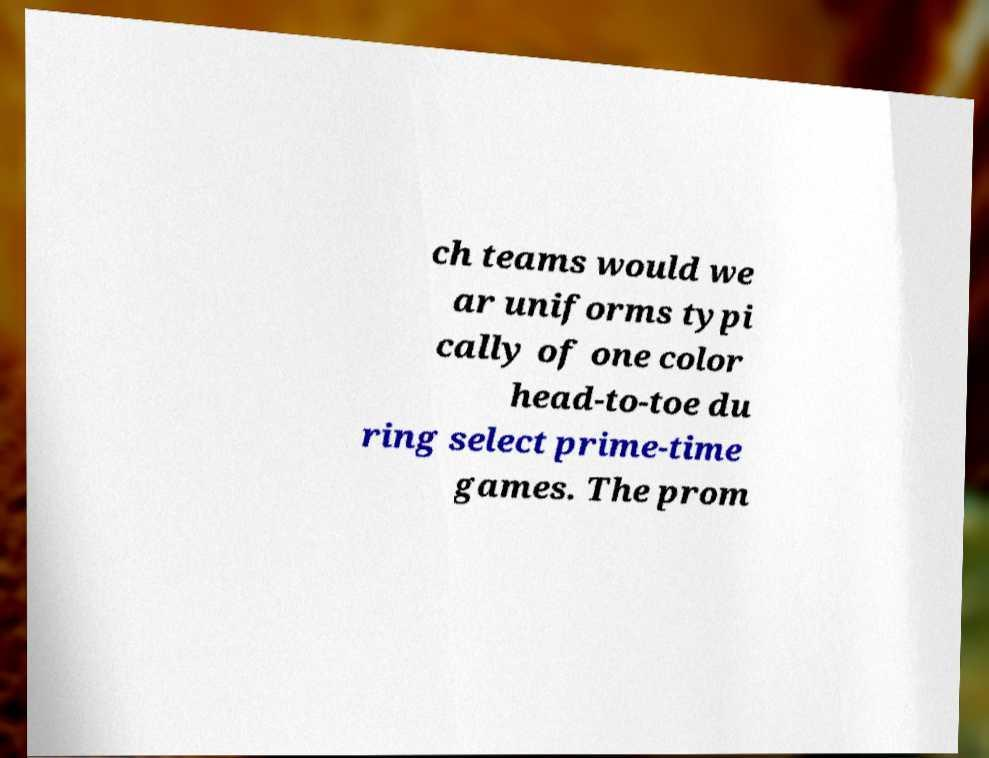I need the written content from this picture converted into text. Can you do that? ch teams would we ar uniforms typi cally of one color head-to-toe du ring select prime-time games. The prom 